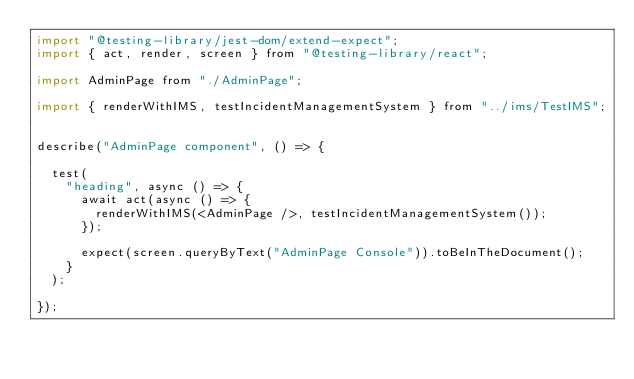Convert code to text. <code><loc_0><loc_0><loc_500><loc_500><_JavaScript_>import "@testing-library/jest-dom/extend-expect";
import { act, render, screen } from "@testing-library/react";

import AdminPage from "./AdminPage";

import { renderWithIMS, testIncidentManagementSystem } from "../ims/TestIMS";


describe("AdminPage component", () => {

  test(
    "heading", async () => {
      await act(async () => {
        renderWithIMS(<AdminPage />, testIncidentManagementSystem());
      });

      expect(screen.queryByText("AdminPage Console")).toBeInTheDocument();
    }
  );

});
</code> 